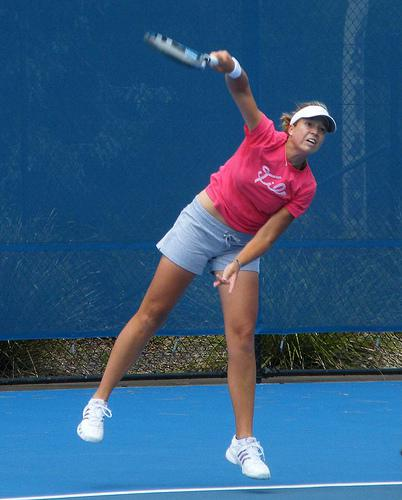Question: who is on the court?
Choices:
A. The child.
B. The woman.
C. The lady.
D. The female.
Answer with the letter. Answer: B Question: how many woman?
Choices:
A. Two.
B. Three.
C. Four.
D. One.
Answer with the letter. Answer: D Question: why is the woman's feet off the ground?
Choices:
A. She's skipping.
B. She's running.
C. She's jumping.
D. She's walking.
Answer with the letter. Answer: C Question: where is the woman?
Choices:
A. Park.
B. Swimming Pool.
C. Tenns court.
D. Movie Theater.
Answer with the letter. Answer: C Question: when was this taken?
Choices:
A. Outdoors.
B. Indoors.
C. In a tent.
D. In a car.
Answer with the letter. Answer: A 